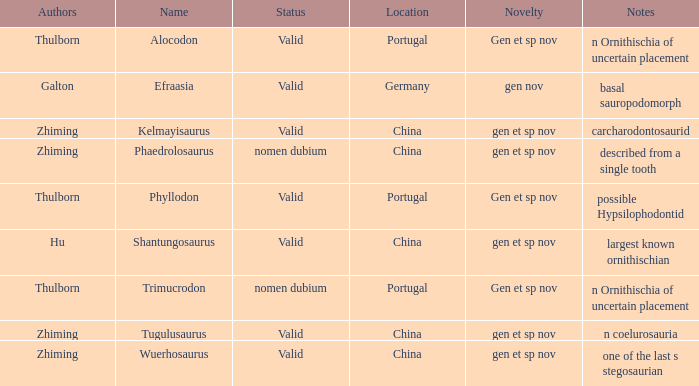What is the Name of the dinosaur, whose notes are, "n ornithischia of uncertain placement"? Alocodon, Trimucrodon. 